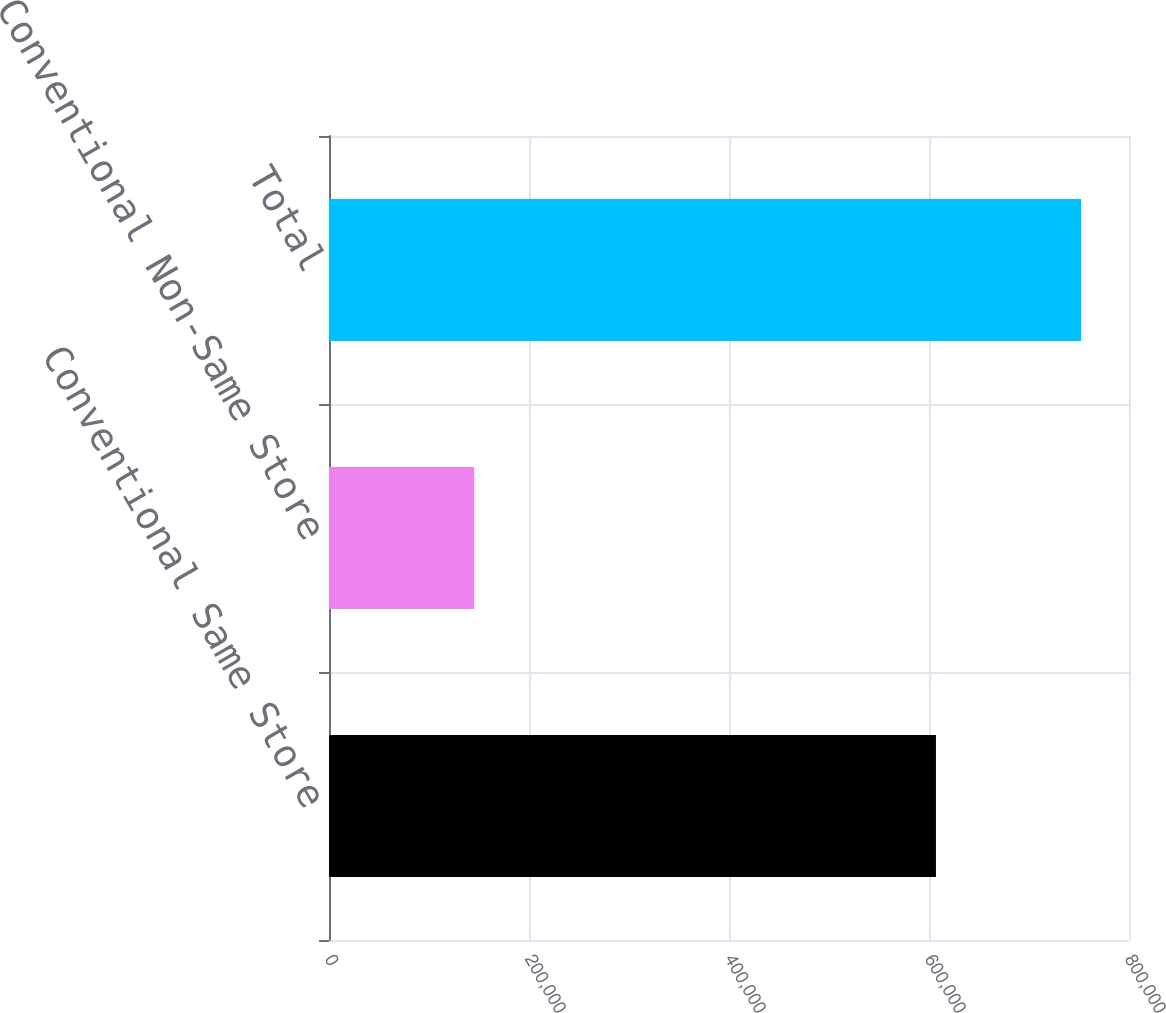Convert chart. <chart><loc_0><loc_0><loc_500><loc_500><bar_chart><fcel>Conventional Same Store<fcel>Conventional Non-Same Store<fcel>Total<nl><fcel>606952<fcel>145189<fcel>752141<nl></chart> 